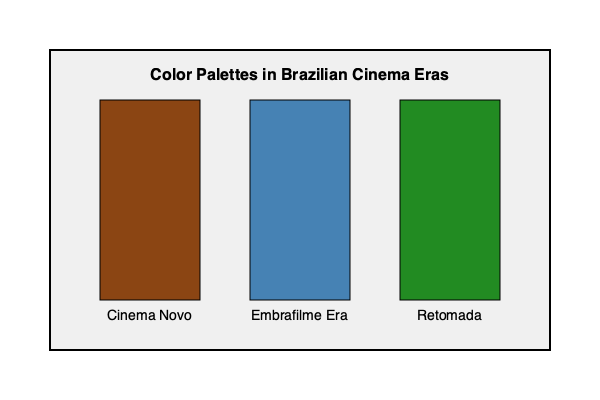Analyze the color palettes represented in the graph for different eras of Brazilian cinema. How do these color choices reflect the artistic and socio-political contexts of each period, and what impact did they have on the visual aesthetics of Brazilian films? To answer this question, we need to examine each era represented in the graph and understand its context:

1. Cinema Novo (1960s-1970s):
   - Represented by a brown color (#8B4513)
   - This earthy tone reflects the movement's focus on rural issues and social realism
   - The color palette often included high-contrast, desaturated images to emphasize harsh realities

2. Embrafilme Era (1970s-1990s):
   - Represented by a steel blue color (#4682B4)
   - This cooler tone suggests a shift towards more urban themes and state-sponsored productions
   - Films of this era often had a broader color palette, with more vibrant and diverse hues

3. Retomada (1990s-2000s):
   - Represented by a forest green color (#228B22)
   - This lush green symbolizes the "rebirth" of Brazilian cinema after a period of decline
   - Films from this era often featured rich, saturated colors to celebrate Brazilian culture and landscapes

The impact of these color choices on visual aesthetics:

- Cinema Novo: The earthy tones and high-contrast images created a stark, raw aesthetic that aligned with the movement's goal of exposing social inequalities.
- Embrafilme Era: The broader palette allowed for more diverse storytelling and genre exploration, reflecting the era's increased production values and state support.
- Retomada: The vibrant colors signaled a return to optimism and a celebration of Brazilian identity, often showcasing the country's natural beauty and cultural diversity.

These color palettes not only reflected the artistic choices of filmmakers but also mirrored the socio-political contexts of their respective eras, contributing to the unique visual language of Brazilian cinema.
Answer: The color palettes reflect each era's socio-political context: Cinema Novo's earthy tones for social realism, Embrafilme's diverse palette for urban themes, and Retomada's vibrant colors for cultural celebration, each shaping the visual aesthetics of Brazilian films. 